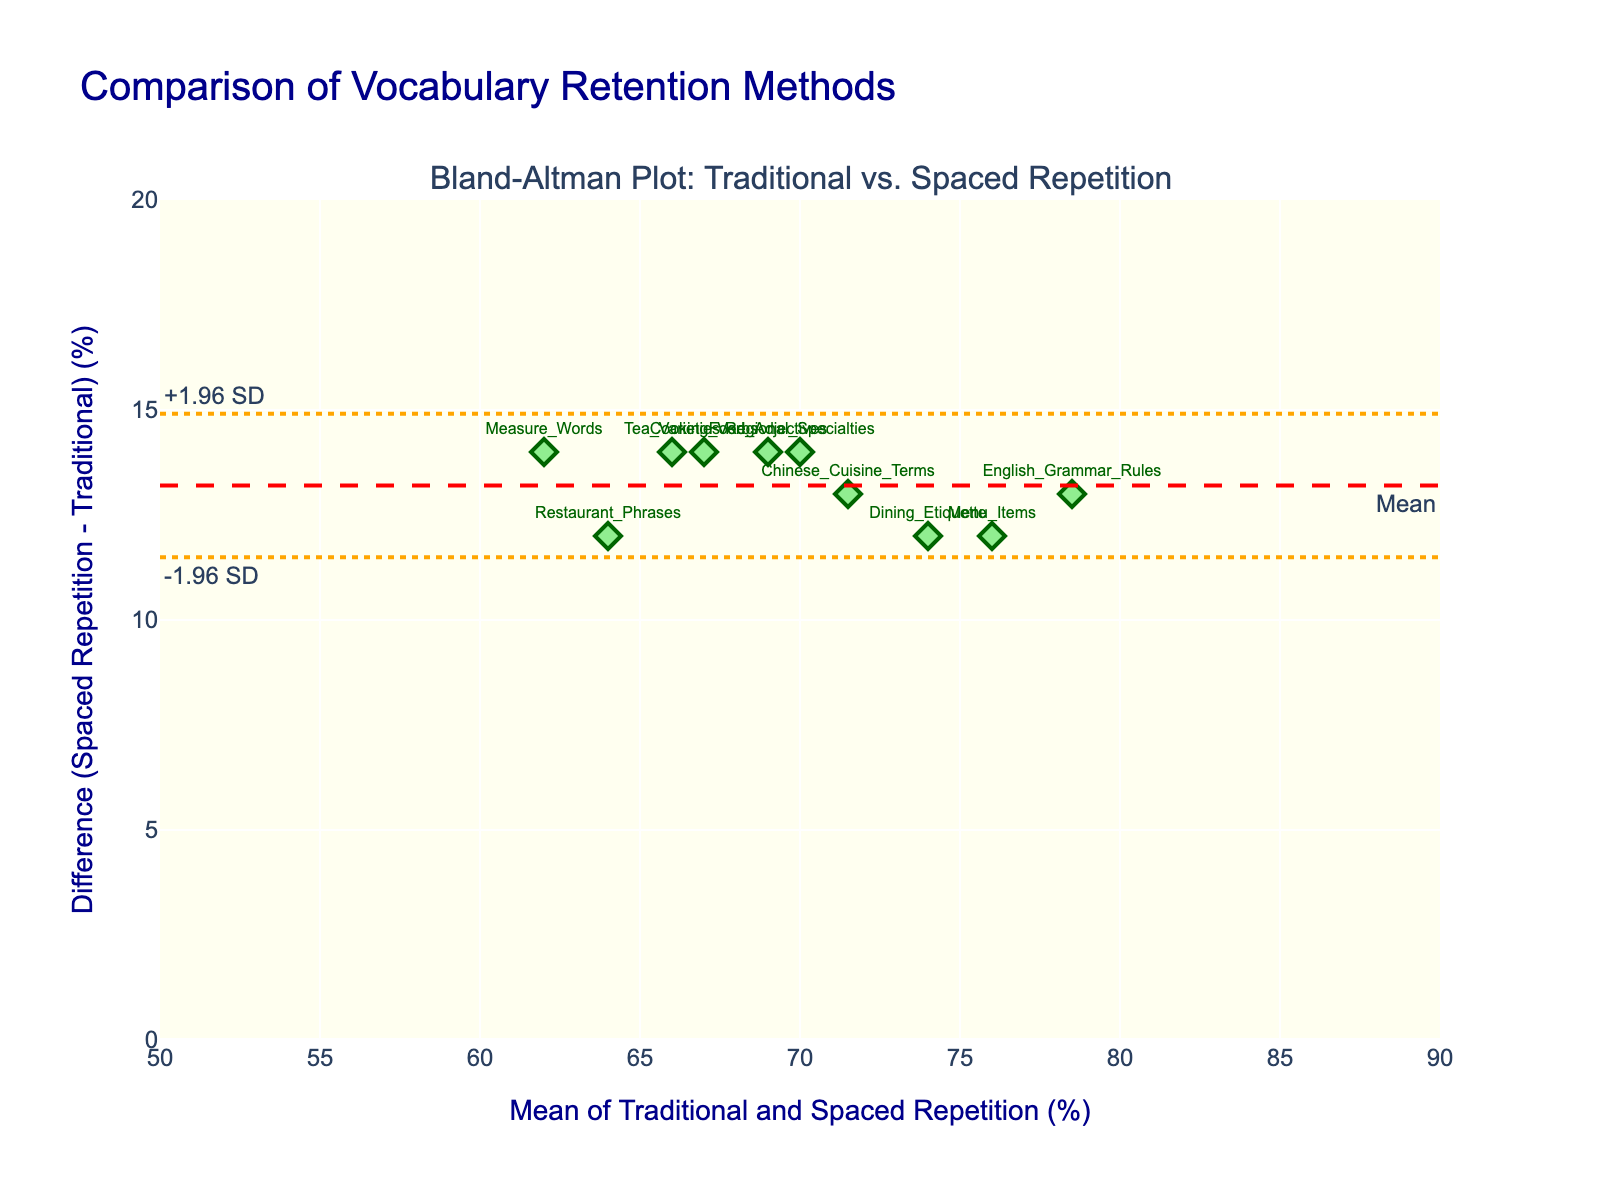What's the title of the figure? The title is written at the top of the figure in large, bold text.
Answer: Comparison of Vocabulary Retention Methods How many data points are represented in the plot? Each marker on the Bland-Altman plot represents a data point. By counting these markers, there are 10 data points.
Answer: 10 What is the range of the x-axis? The x-axis represents the "Mean of Traditional and Spaced Repetition (%)" and spans from 50 to 90.
Answer: 50 to 90 What does the red dashed line on the plot represent? The red dashed line is annotated as "Mean" and represents the mean difference between the Traditional Flashcards and Spaced Repetition Software.
Answer: Mean difference Which method has a better vocabulary retention rate, Traditional Flashcards or Spaced Repetition Software? In the Bland-Altman plot, the majority of data points are above the x-axis, indicating that Spaced Repetition Software generally has higher retention rates compared to Traditional Flashcards.
Answer: Spaced Repetition Software Which data point has the smallest difference between the two methods? Find the marker closest to the x-axis (smallest y-value difference). The "Dining Etiquette" term is the closest.
Answer: Dining Etiquette What are the limits of agreement in this plot? The limits of agreement are represented by the orange dotted lines denoted as "-1.96 SD" and "+1.96 SD" from the mean difference line.
Answer: -1.96 SD and +1.96 SD What is the mean difference in vocabulary retention rates between the two methods? The plot has a red dashed line labelled "Mean" showing the average difference between the methods, which appears to be around 12%.
Answer: Approximately 12% Which subject area has the largest difference in retention rates between the two methods? Identify the marker farthest from the x-axis (largest y-value difference). "Restaurant Phrases" term shows the largest difference.
Answer: Restaurant Phrases What does a positive difference indicate in this plot? A positive difference (above the x-axis) means Spaced Repetition Software has a higher retention rate for that term compared to Traditional Flashcards.
Answer: Spaced Repetition is higher 